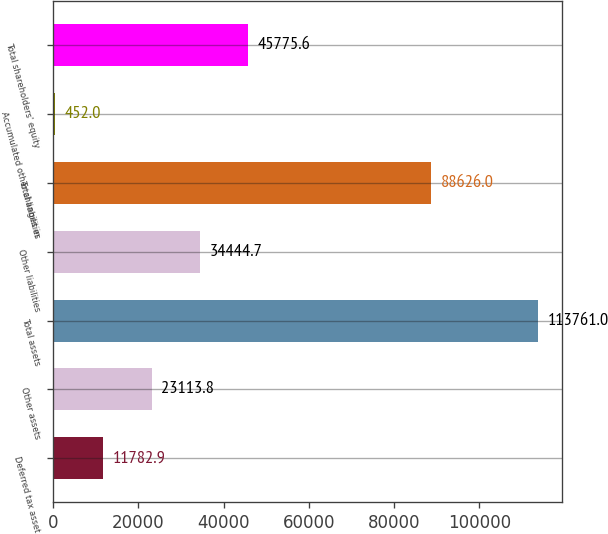Convert chart. <chart><loc_0><loc_0><loc_500><loc_500><bar_chart><fcel>Deferred tax asset<fcel>Other assets<fcel>Total assets<fcel>Other liabilities<fcel>Total liabilities<fcel>Accumulated other changes in<fcel>Total shareholders' equity<nl><fcel>11782.9<fcel>23113.8<fcel>113761<fcel>34444.7<fcel>88626<fcel>452<fcel>45775.6<nl></chart> 